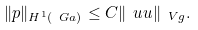Convert formula to latex. <formula><loc_0><loc_0><loc_500><loc_500>\| p \| _ { H ^ { 1 } ( \ G a ) } \leq C \| \ u u \| _ { \ V g } .</formula> 